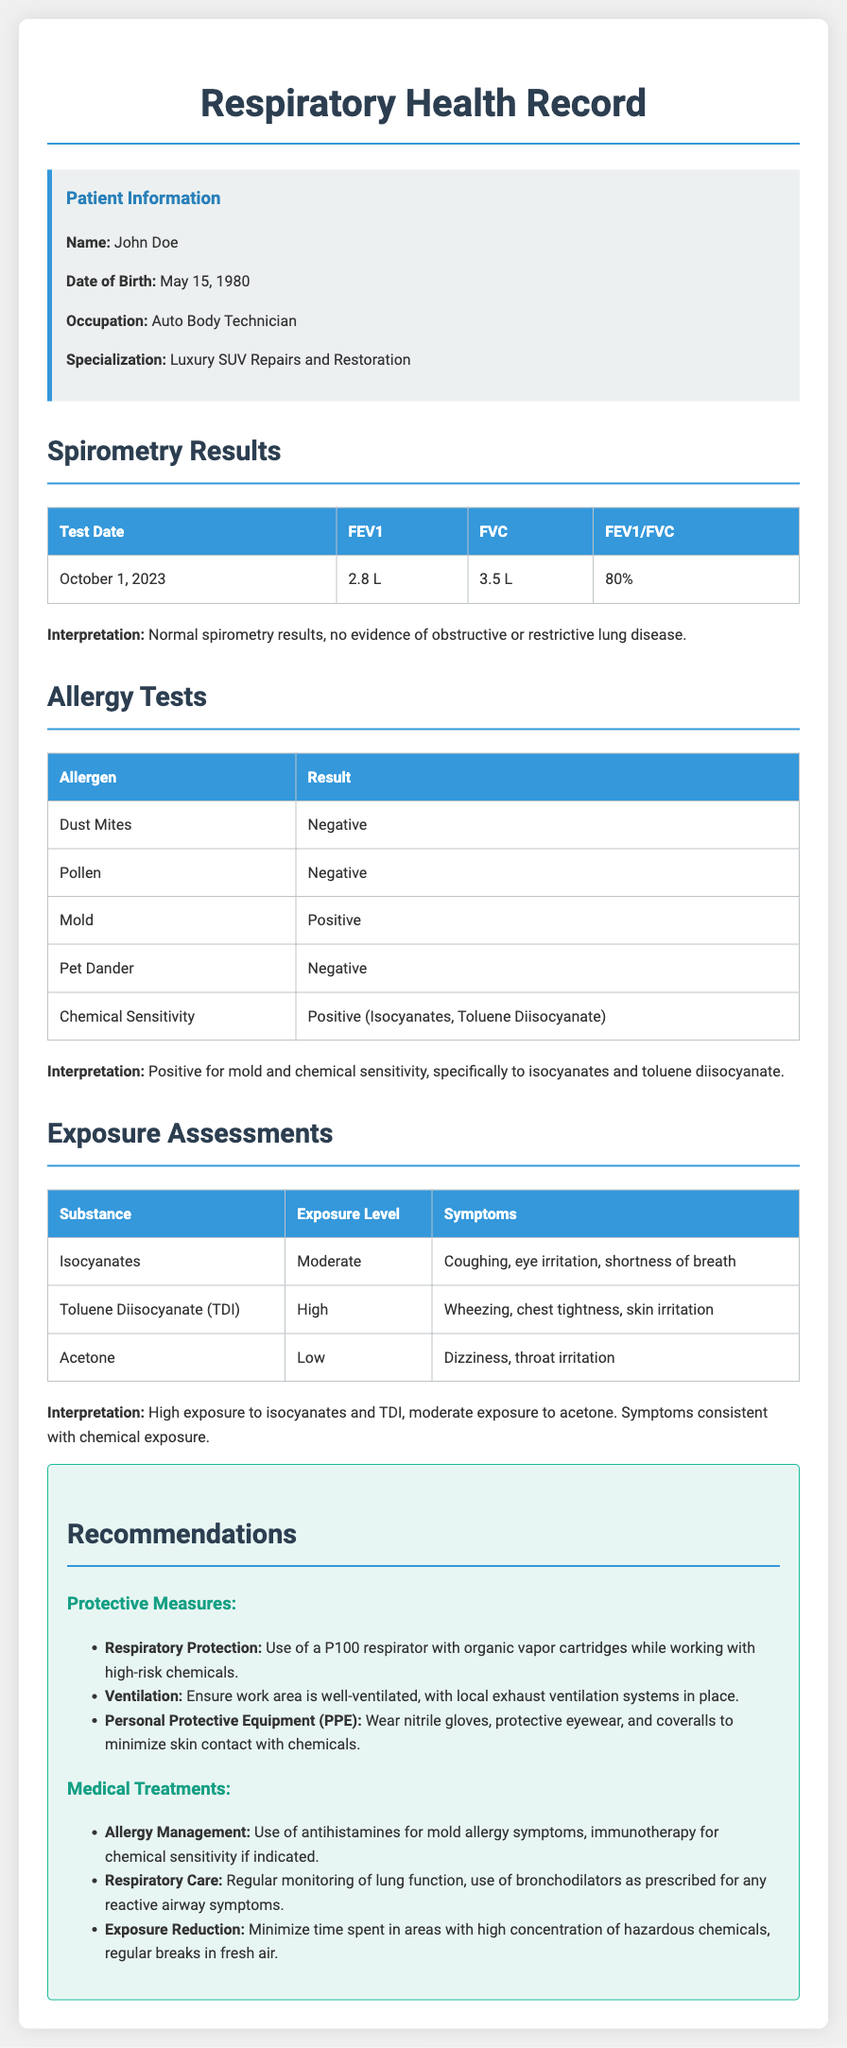What is the name of the patient? The patient's name is listed in the patient information section of the document.
Answer: John Doe What was the FEV1 result on October 1, 2023? The FEV1 result is found in the spirometry results table dated October 1, 2023.
Answer: 2.8 L What chemical sensitivity was reported? The type of chemical sensitivity is recorded under the allergy tests section.
Answer: Isocyanates, Toluene Diisocyanate What were the symptoms for high exposure to Toluene Diisocyanate? Symptoms related to exposure are documented in the exposure assessments section of the document.
Answer: Wheezing, chest tightness, skin irritation What is the recommended respiratory protection? The recommendations section specifies protective measures for respiratory safety.
Answer: P100 respirator with organic vapor cartridges What is the patient's occupation? The document includes the patient's occupation in the patient information block.
Answer: Auto Body Technician What is the interpretation of the spirometry results? The interpretation is based on the spirometry results summarized at the end of that section.
Answer: Normal spirometry results, no evidence of obstructive or restrictive lung disease What type of allergy management is suggested in the recommendations? The recommendations for medical treatments explicitly mention the management strategies for allergies.
Answer: Antihistamines for mold allergy symptoms 